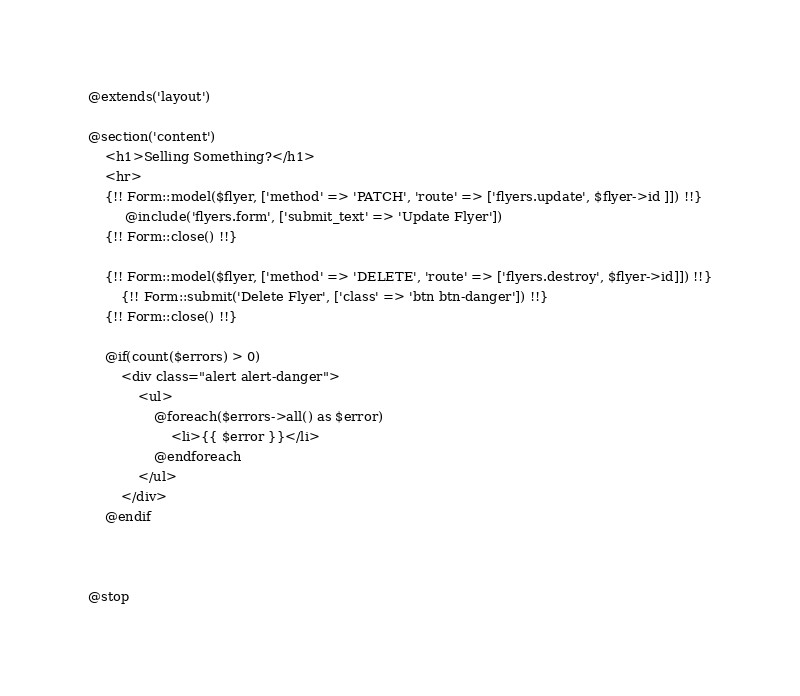Convert code to text. <code><loc_0><loc_0><loc_500><loc_500><_PHP_>@extends('layout')

@section('content')
    <h1>Selling Something?</h1>
    <hr>
    {!! Form::model($flyer, ['method' => 'PATCH', 'route' => ['flyers.update', $flyer->id ]]) !!}
         @include('flyers.form', ['submit_text' => 'Update Flyer'])
    {!! Form::close() !!}

    {!! Form::model($flyer, ['method' => 'DELETE', 'route' => ['flyers.destroy', $flyer->id]]) !!}
        {!! Form::submit('Delete Flyer', ['class' => 'btn btn-danger']) !!}
    {!! Form::close() !!}

    @if(count($errors) > 0)
        <div class="alert alert-danger">
            <ul>
                @foreach($errors->all() as $error)
                    <li>{{ $error }}</li>
                @endforeach
            </ul>
        </div>
    @endif



@stop</code> 